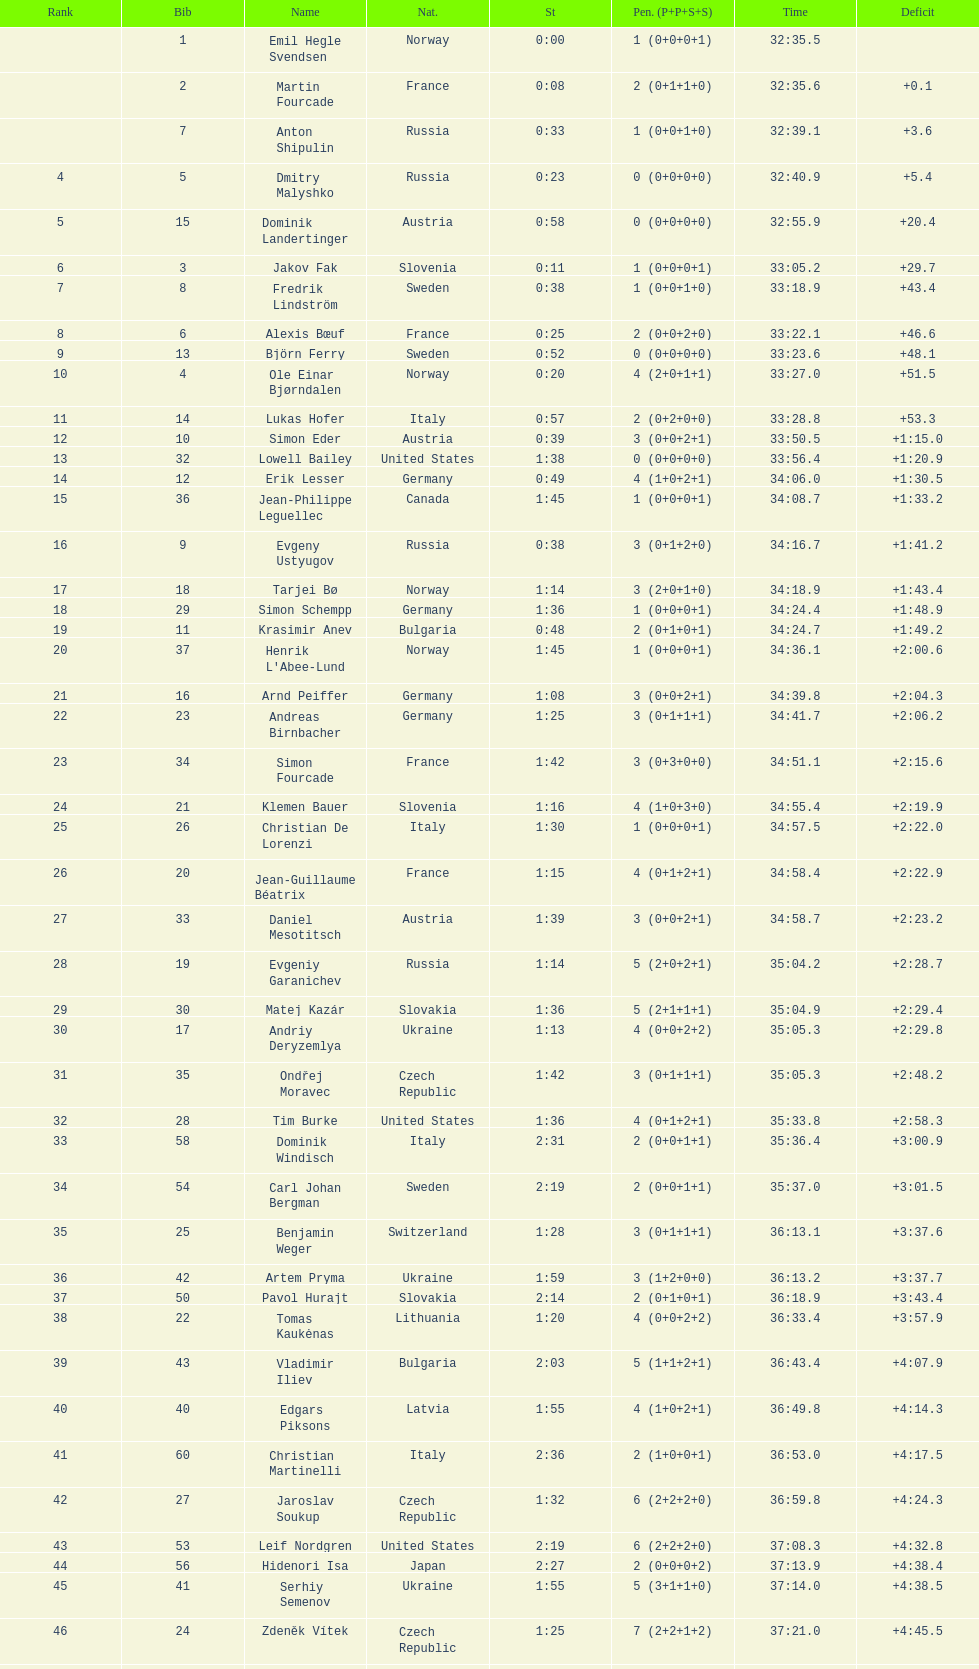Between bjorn ferry, simon elder and erik lesser - who had the most penalties? Erik Lesser. Would you mind parsing the complete table? {'header': ['Rank', 'Bib', 'Name', 'Nat.', 'St', 'Pen. (P+P+S+S)', 'Time', 'Deficit'], 'rows': [['', '1', 'Emil Hegle Svendsen', 'Norway', '0:00', '1 (0+0+0+1)', '32:35.5', ''], ['', '2', 'Martin Fourcade', 'France', '0:08', '2 (0+1+1+0)', '32:35.6', '+0.1'], ['', '7', 'Anton Shipulin', 'Russia', '0:33', '1 (0+0+1+0)', '32:39.1', '+3.6'], ['4', '5', 'Dmitry Malyshko', 'Russia', '0:23', '0 (0+0+0+0)', '32:40.9', '+5.4'], ['5', '15', 'Dominik Landertinger', 'Austria', '0:58', '0 (0+0+0+0)', '32:55.9', '+20.4'], ['6', '3', 'Jakov Fak', 'Slovenia', '0:11', '1 (0+0+0+1)', '33:05.2', '+29.7'], ['7', '8', 'Fredrik Lindström', 'Sweden', '0:38', '1 (0+0+1+0)', '33:18.9', '+43.4'], ['8', '6', 'Alexis Bœuf', 'France', '0:25', '2 (0+0+2+0)', '33:22.1', '+46.6'], ['9', '13', 'Björn Ferry', 'Sweden', '0:52', '0 (0+0+0+0)', '33:23.6', '+48.1'], ['10', '4', 'Ole Einar Bjørndalen', 'Norway', '0:20', '4 (2+0+1+1)', '33:27.0', '+51.5'], ['11', '14', 'Lukas Hofer', 'Italy', '0:57', '2 (0+2+0+0)', '33:28.8', '+53.3'], ['12', '10', 'Simon Eder', 'Austria', '0:39', '3 (0+0+2+1)', '33:50.5', '+1:15.0'], ['13', '32', 'Lowell Bailey', 'United States', '1:38', '0 (0+0+0+0)', '33:56.4', '+1:20.9'], ['14', '12', 'Erik Lesser', 'Germany', '0:49', '4 (1+0+2+1)', '34:06.0', '+1:30.5'], ['15', '36', 'Jean-Philippe Leguellec', 'Canada', '1:45', '1 (0+0+0+1)', '34:08.7', '+1:33.2'], ['16', '9', 'Evgeny Ustyugov', 'Russia', '0:38', '3 (0+1+2+0)', '34:16.7', '+1:41.2'], ['17', '18', 'Tarjei Bø', 'Norway', '1:14', '3 (2+0+1+0)', '34:18.9', '+1:43.4'], ['18', '29', 'Simon Schempp', 'Germany', '1:36', '1 (0+0+0+1)', '34:24.4', '+1:48.9'], ['19', '11', 'Krasimir Anev', 'Bulgaria', '0:48', '2 (0+1+0+1)', '34:24.7', '+1:49.2'], ['20', '37', "Henrik L'Abee-Lund", 'Norway', '1:45', '1 (0+0+0+1)', '34:36.1', '+2:00.6'], ['21', '16', 'Arnd Peiffer', 'Germany', '1:08', '3 (0+0+2+1)', '34:39.8', '+2:04.3'], ['22', '23', 'Andreas Birnbacher', 'Germany', '1:25', '3 (0+1+1+1)', '34:41.7', '+2:06.2'], ['23', '34', 'Simon Fourcade', 'France', '1:42', '3 (0+3+0+0)', '34:51.1', '+2:15.6'], ['24', '21', 'Klemen Bauer', 'Slovenia', '1:16', '4 (1+0+3+0)', '34:55.4', '+2:19.9'], ['25', '26', 'Christian De Lorenzi', 'Italy', '1:30', '1 (0+0+0+1)', '34:57.5', '+2:22.0'], ['26', '20', 'Jean-Guillaume Béatrix', 'France', '1:15', '4 (0+1+2+1)', '34:58.4', '+2:22.9'], ['27', '33', 'Daniel Mesotitsch', 'Austria', '1:39', '3 (0+0+2+1)', '34:58.7', '+2:23.2'], ['28', '19', 'Evgeniy Garanichev', 'Russia', '1:14', '5 (2+0+2+1)', '35:04.2', '+2:28.7'], ['29', '30', 'Matej Kazár', 'Slovakia', '1:36', '5 (2+1+1+1)', '35:04.9', '+2:29.4'], ['30', '17', 'Andriy Deryzemlya', 'Ukraine', '1:13', '4 (0+0+2+2)', '35:05.3', '+2:29.8'], ['31', '35', 'Ondřej Moravec', 'Czech Republic', '1:42', '3 (0+1+1+1)', '35:05.3', '+2:48.2'], ['32', '28', 'Tim Burke', 'United States', '1:36', '4 (0+1+2+1)', '35:33.8', '+2:58.3'], ['33', '58', 'Dominik Windisch', 'Italy', '2:31', '2 (0+0+1+1)', '35:36.4', '+3:00.9'], ['34', '54', 'Carl Johan Bergman', 'Sweden', '2:19', '2 (0+0+1+1)', '35:37.0', '+3:01.5'], ['35', '25', 'Benjamin Weger', 'Switzerland', '1:28', '3 (0+1+1+1)', '36:13.1', '+3:37.6'], ['36', '42', 'Artem Pryma', 'Ukraine', '1:59', '3 (1+2+0+0)', '36:13.2', '+3:37.7'], ['37', '50', 'Pavol Hurajt', 'Slovakia', '2:14', '2 (0+1+0+1)', '36:18.9', '+3:43.4'], ['38', '22', 'Tomas Kaukėnas', 'Lithuania', '1:20', '4 (0+0+2+2)', '36:33.4', '+3:57.9'], ['39', '43', 'Vladimir Iliev', 'Bulgaria', '2:03', '5 (1+1+2+1)', '36:43.4', '+4:07.9'], ['40', '40', 'Edgars Piksons', 'Latvia', '1:55', '4 (1+0+2+1)', '36:49.8', '+4:14.3'], ['41', '60', 'Christian Martinelli', 'Italy', '2:36', '2 (1+0+0+1)', '36:53.0', '+4:17.5'], ['42', '27', 'Jaroslav Soukup', 'Czech Republic', '1:32', '6 (2+2+2+0)', '36:59.8', '+4:24.3'], ['43', '53', 'Leif Nordgren', 'United States', '2:19', '6 (2+2+2+0)', '37:08.3', '+4:32.8'], ['44', '56', 'Hidenori Isa', 'Japan', '2:27', '2 (0+0+0+2)', '37:13.9', '+4:38.4'], ['45', '41', 'Serhiy Semenov', 'Ukraine', '1:55', '5 (3+1+1+0)', '37:14.0', '+4:38.5'], ['46', '24', 'Zdeněk Vítek', 'Czech Republic', '1:25', '7 (2+2+1+2)', '37:21.0', '+4:45.5'], ['47', '49', 'Milanko Petrović', 'Serbia', '2:14', '6 (2+2+2+0)', '37:26.6', '+4:51.1'], ['48', '31', 'Kauri Kõiv', 'Estonia', '1:37', '6 (2+1+2+1)', '37:29.9', '+4:54.4'], ['49', '47', 'Yan Savitskiy', 'Kazakhstan', '2:11', '5 (2+2+0+1)', '37:51.8', '+5:16.3'], ['50', '45', 'Scott Gow', 'Canada', '2:06', '5 (0+0+1+4)', '37:57.4', '+5:21.9'], ['51', '48', 'Claudio Böckli', 'Switzerland', '2:13', '3 (2+0+0+1)', '38:02.8', '+5:27.3'], ['52', '44', 'Russell Currier', 'United States', '2:05', '7 (3+1+2+1)', '38:06.2', '+5:30.7'], ['53', '57', 'Vladimir Chepelin', 'Belarus', '2:28', '4 (0+1+2+1)', '38:06.5', '+5:31.0'], ['54', '46', 'Aliaksandr Babchyn', 'Belarus', '2:06', '6 (3+2+1+0)', '38:19.8', '+5:44.3'], ['55', '59', 'Miroslav Matiaško', 'Slovakia', '2:36', '6 (3+0+2+1)', '38:54.6', '+6:19.1'], ['56', '38', 'Jarkko Kauppinen', 'Finland', '1:46', '6 (1+1+3+1)', '39:06.6', '+6:31.1'], ['57', '51', 'Junji Nagai', 'Japan', '2:17', '7 (0+2+3+2)', '39:49.9', '+7:14.4'], ['', '55', 'Stefan Gavrila', 'Romania', '2:25', '10 (4+3+3)', 'LAP', ''], ['', '39', 'Sergei Sednev', 'Ukraine', '1:54', '', 'DNS', ''], ['', '52', 'Michal Šlesingr', 'Czech Republic', '2:18', '', 'DNS', '']]} 